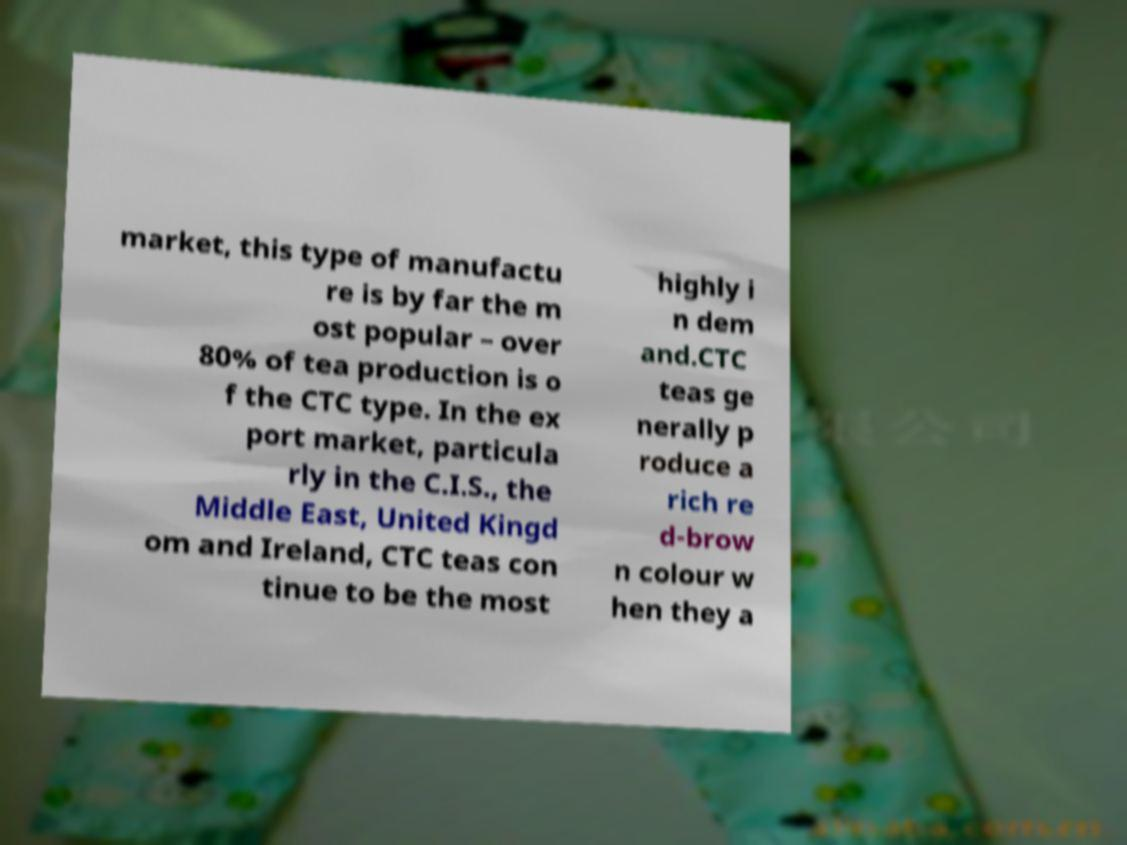Could you assist in decoding the text presented in this image and type it out clearly? market, this type of manufactu re is by far the m ost popular – over 80% of tea production is o f the CTC type. In the ex port market, particula rly in the C.I.S., the Middle East, United Kingd om and Ireland, CTC teas con tinue to be the most highly i n dem and.CTC teas ge nerally p roduce a rich re d-brow n colour w hen they a 